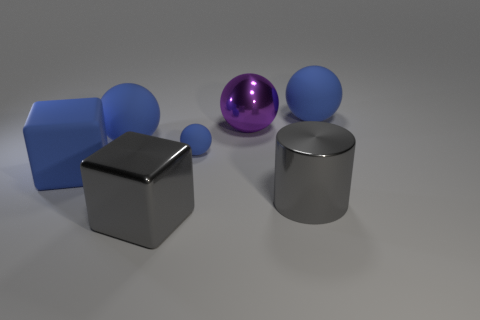Subtract all yellow blocks. How many blue balls are left? 3 Add 2 blue balls. How many objects exist? 9 Subtract all cubes. How many objects are left? 5 Subtract 1 gray blocks. How many objects are left? 6 Subtract all tiny blue matte spheres. Subtract all large spheres. How many objects are left? 3 Add 4 blue rubber cubes. How many blue rubber cubes are left? 5 Add 4 tiny matte things. How many tiny matte things exist? 5 